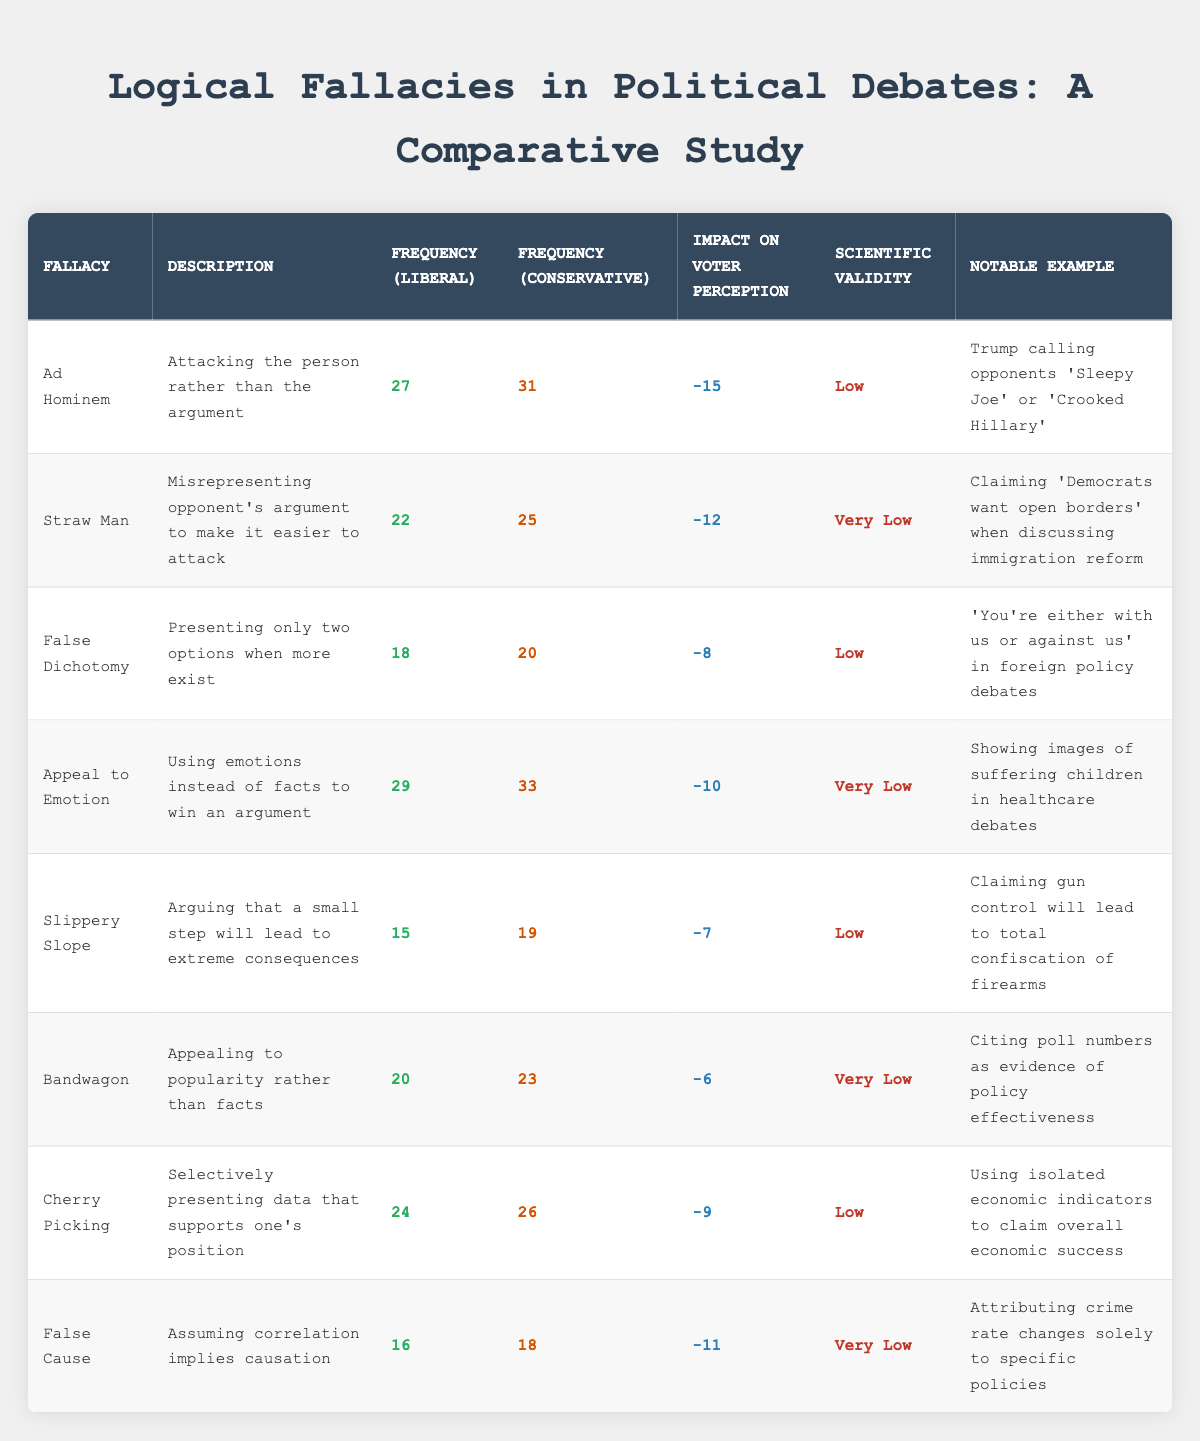What is the frequency of the Ad Hominem fallacy among conservatives? The table lists the frequency of the Ad Hominem fallacy for conservatives as 31. This value can be found directly in the relevant column of the Ad Hominem row.
Answer: 31 Which logical fallacy has the highest impact on voter perception according to the table? The impact on voter perception for each fallacy is listed with Ad Hominem having the most significant negative impact at -15. By comparing the impact values, we see that Ad Hominem has the lowest value (most negative), indicating the highest impact.
Answer: Ad Hominem What is the average frequency of logical fallacies for liberals? To find the average frequency for liberals, sum the frequencies: 27 (Ad Hominem) + 22 (Straw Man) + 18 (False Dichotomy) + 29 (Appeal to Emotion) + 15 (Slippery Slope) + 20 (Bandwagon) + 24 (Cherry Picking) + 16 (False Cause) = 171. There are 8 fallacies, so the average is 171/8 = 21.375.
Answer: 21.375 Is the statement "Appeal to Emotion is more frequently used by conservatives than liberals" true or false? From the table, the frequency of Appeal to Emotion for liberals is 29, while conservatives is 33. Since 33 is greater than 29, the statement is true.
Answer: True How much more frequently do conservatives use the Straw Man fallacy compared to liberals? The frequency of the Straw Man fallacy for conservatives is 25, and for liberals, it is 22. By subtracting these values, 25 - 22 = 3, we find that conservatives use the Straw Man fallacy 3 times more frequently than liberals.
Answer: 3 What is the scientific validity rating for the False Cause fallacy? The table provides a description of scientific validity for each fallacy; for False Cause, the rating is listed as "Very Low". This information can be directly found in the corresponding row and column for that fallacy.
Answer: Very Low Which fallacy has the least negative impact on voter perception? By reviewing the impact values in the table, the fallacy with the least negative impact is Bandwagon, with an impact of -6. This can be deduced by looking through all the impact values and identifying the least negative.
Answer: Bandwagon What is the total frequency of the fallacy "Cherry Picking" for both political groups? The frequency of Cherry Picking is 24 for liberals and 26 for conservatives. We add these together: 24 + 26 = 50.
Answer: 50 How many logical fallacies in the table have a scientific validity rating of "Low"? By examining each entry, the logical fallacies with "Low" scientific validity include Ad Hominem, False Dichotomy, Slippery Slope, Cherry Picking, totaling 4 fallacies. This count involves reading the scientific validity column and tallying each fallacy that matches.
Answer: 4 